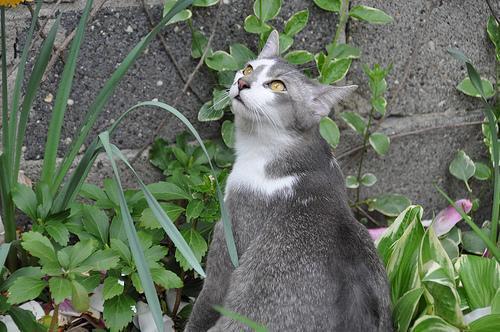How many cats are in the picture?
Give a very brief answer. 1. 